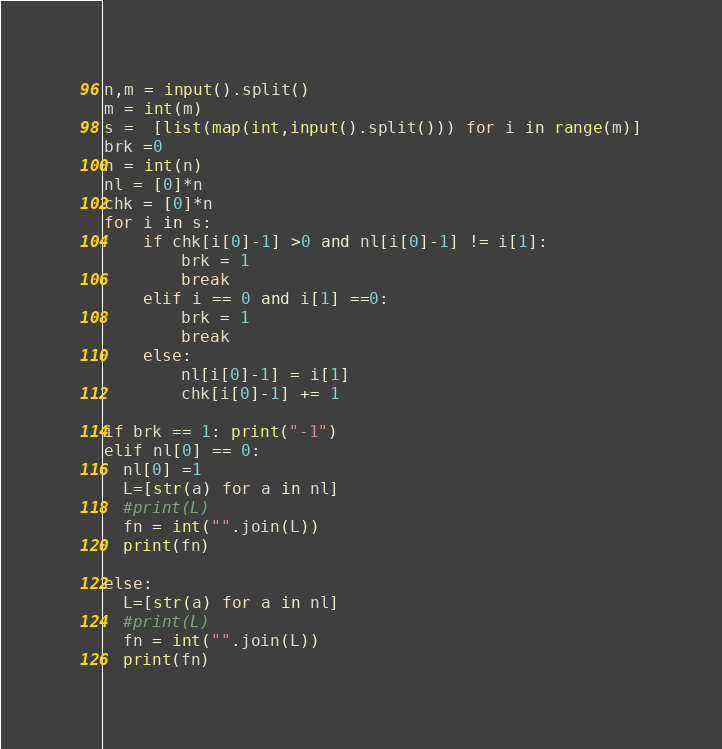<code> <loc_0><loc_0><loc_500><loc_500><_Python_>n,m = input().split()
m = int(m)
s =  [list(map(int,input().split())) for i in range(m)]
brk =0
n = int(n)
nl = [0]*n
chk = [0]*n
for i in s:
    if chk[i[0]-1] >0 and nl[i[0]-1] != i[1]:
        brk = 1
        break
    elif i == 0 and i[1] ==0:
        brk = 1
        break
    else:
        nl[i[0]-1] = i[1]
        chk[i[0]-1] += 1

if brk == 1: print("-1")
elif nl[0] == 0:
  nl[0] =1
  L=[str(a) for a in nl]
  #print(L)
  fn = int("".join(L))
  print(fn)

else:
  L=[str(a) for a in nl]
  #print(L)
  fn = int("".join(L))
  print(fn)</code> 